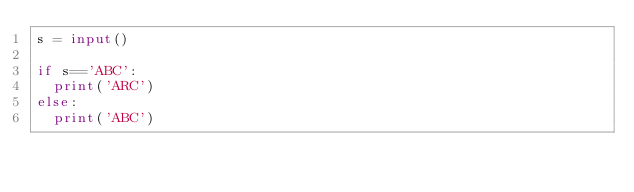<code> <loc_0><loc_0><loc_500><loc_500><_Python_>s = input()

if s=='ABC':
  print('ARC')
else:
  print('ABC')</code> 